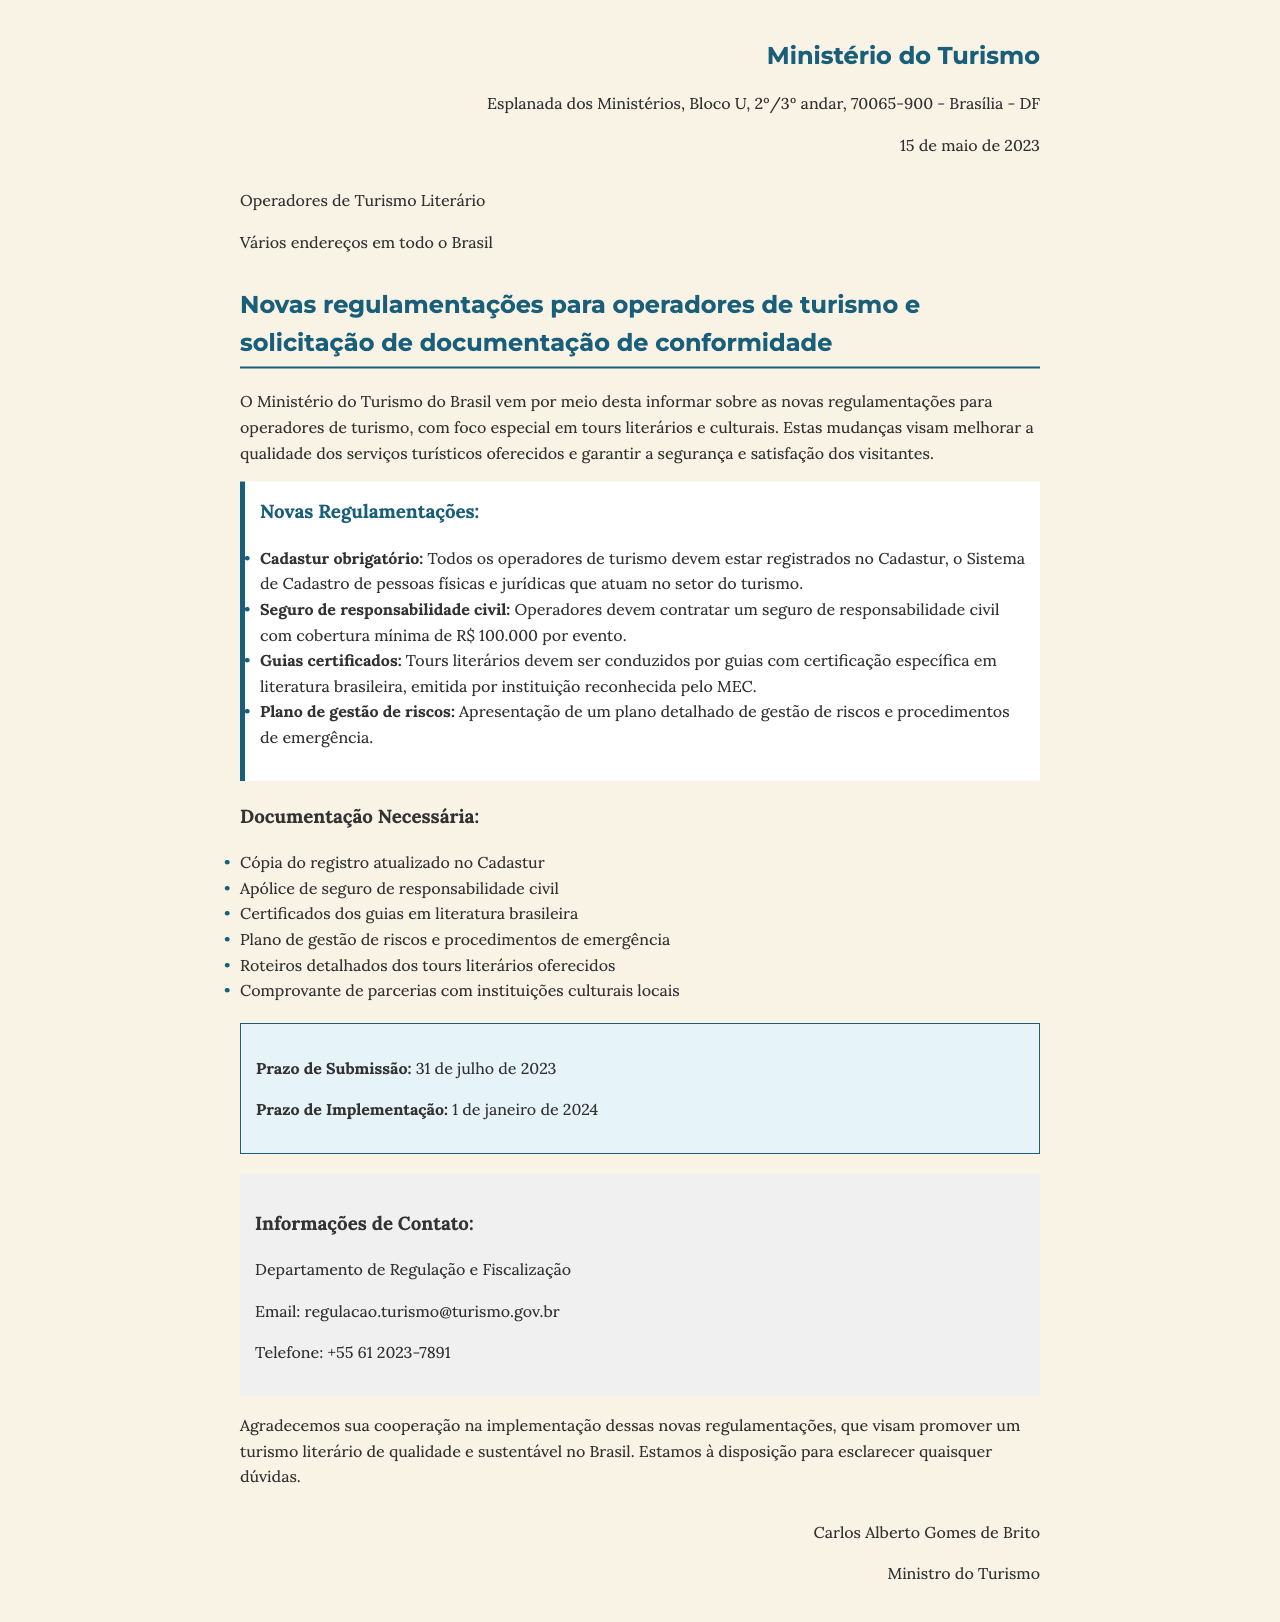What is the sender of the letter? The sender is stated at the top of the letter, which is the Ministério do Turismo.
Answer: Ministério do Turismo What date was the letter written? The date of the letter is mentioned in the header, which is 15 de maio de 2023.
Answer: 15 de maio de 2023 What is the subject of the letter? The subject is outlined after the recipient information and states the focus of the letter.
Answer: Novas regulamentações para operadores de turismo e solicitação de documentação de conformidade What is the minimum coverage required for the insurance? The document specifies the coverage amount required for insurance by operators.
Answer: R$ 100.000 por evento What is one required document for compliance? The letter lists several documents required for compliance.
Answer: Cópia do registro atualizado no Cadastur What is the deadline for submitting documentation? The letter provides a specific date for when the documentation must be submitted.
Answer: 31 de julho de 2023 What must tours be conducted by? The letter mentions a requirement regarding who can conduct the tours.
Answer: Guias com certificação específica em literatura brasileira Who is the recipient of the letter? The recipient's name is stated in the document, referring to the target audience of the regulations.
Answer: Operadores de Turismo Literário What is the contact department's email? The contact information section provides an email for further inquiries regarding the new regulations.
Answer: regulacao.turismo@turismo.gov.br 